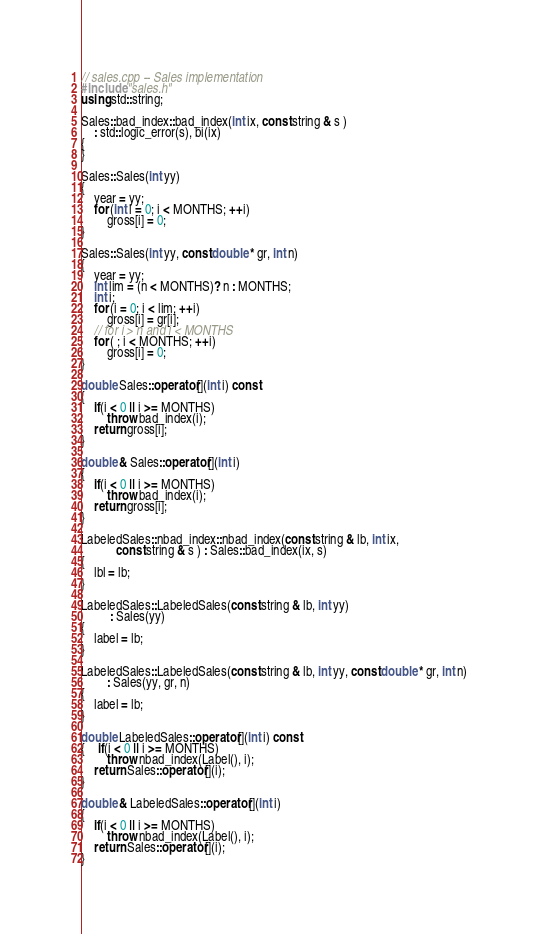Convert code to text. <code><loc_0><loc_0><loc_500><loc_500><_C++_>// sales.cpp -- Sales implementation
#include "sales.h"
using std::string;

Sales::bad_index::bad_index(int ix, const string & s )
    : std::logic_error(s), bi(ix)
{
}

Sales::Sales(int yy)
{
    year = yy;
    for (int i = 0; i < MONTHS; ++i)
        gross[i] = 0;
}

Sales::Sales(int yy, const double * gr, int n)
{
    year = yy;
    int lim = (n < MONTHS)? n : MONTHS;
    int i;
    for (i = 0; i < lim; ++i)
        gross[i] = gr[i];
    // for i > n and i < MONTHS
    for ( ; i < MONTHS; ++i)
        gross[i] = 0;
}

double Sales::operator[](int i) const
{
    if(i < 0 || i >= MONTHS)
        throw bad_index(i);
    return gross[i];
}

double & Sales::operator[](int i)
{
    if(i < 0 || i >= MONTHS)
        throw bad_index(i);
    return gross[i];
}

LabeledSales::nbad_index::nbad_index(const string & lb, int ix,
           const string & s ) : Sales::bad_index(ix, s)
{
    lbl = lb;
}

LabeledSales::LabeledSales(const string & lb, int yy)
         : Sales(yy)
{
    label = lb;
}

LabeledSales::LabeledSales(const string & lb, int yy, const double * gr, int n)
        : Sales(yy, gr, n)
{
    label = lb;
}

double LabeledSales::operator[](int i) const
{    if(i < 0 || i >= MONTHS)
        throw nbad_index(Label(), i);
    return Sales::operator[](i);
}

double & LabeledSales::operator[](int i)
{
    if(i < 0 || i >= MONTHS)
        throw nbad_index(Label(), i);
    return Sales::operator[](i);
}
</code> 